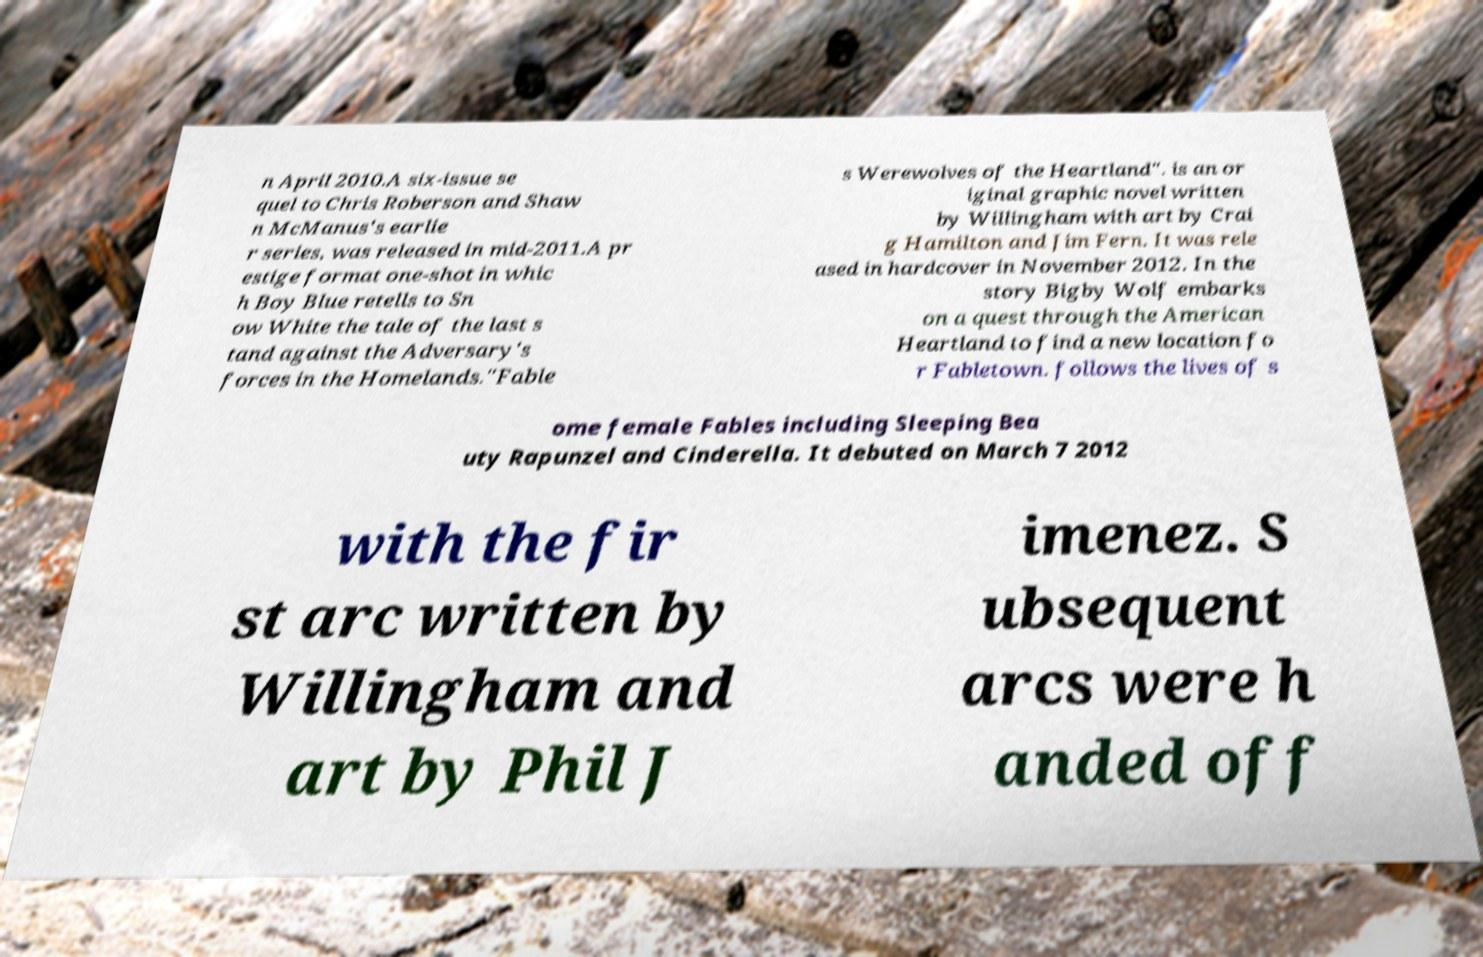Please identify and transcribe the text found in this image. n April 2010.A six-issue se quel to Chris Roberson and Shaw n McManus's earlie r series, was released in mid-2011.A pr estige format one-shot in whic h Boy Blue retells to Sn ow White the tale of the last s tand against the Adversary's forces in the Homelands."Fable s Werewolves of the Heartland". is an or iginal graphic novel written by Willingham with art by Crai g Hamilton and Jim Fern. It was rele ased in hardcover in November 2012. In the story Bigby Wolf embarks on a quest through the American Heartland to find a new location fo r Fabletown. follows the lives of s ome female Fables including Sleeping Bea uty Rapunzel and Cinderella. It debuted on March 7 2012 with the fir st arc written by Willingham and art by Phil J imenez. S ubsequent arcs were h anded off 